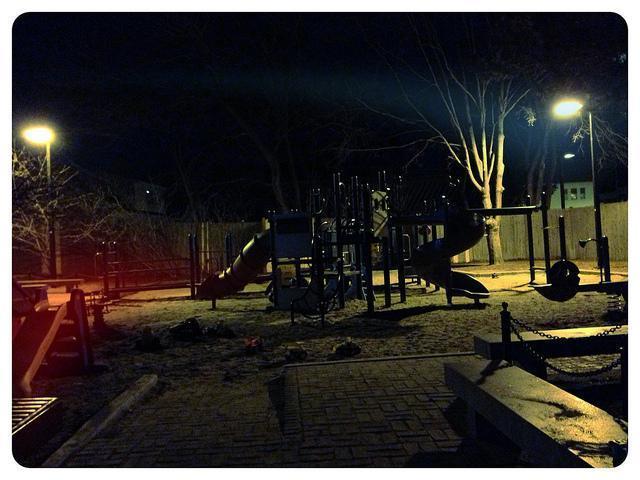How many trees are there?
Give a very brief answer. 2. How many people are in the scene?
Give a very brief answer. 0. How many benches can be seen?
Give a very brief answer. 2. 